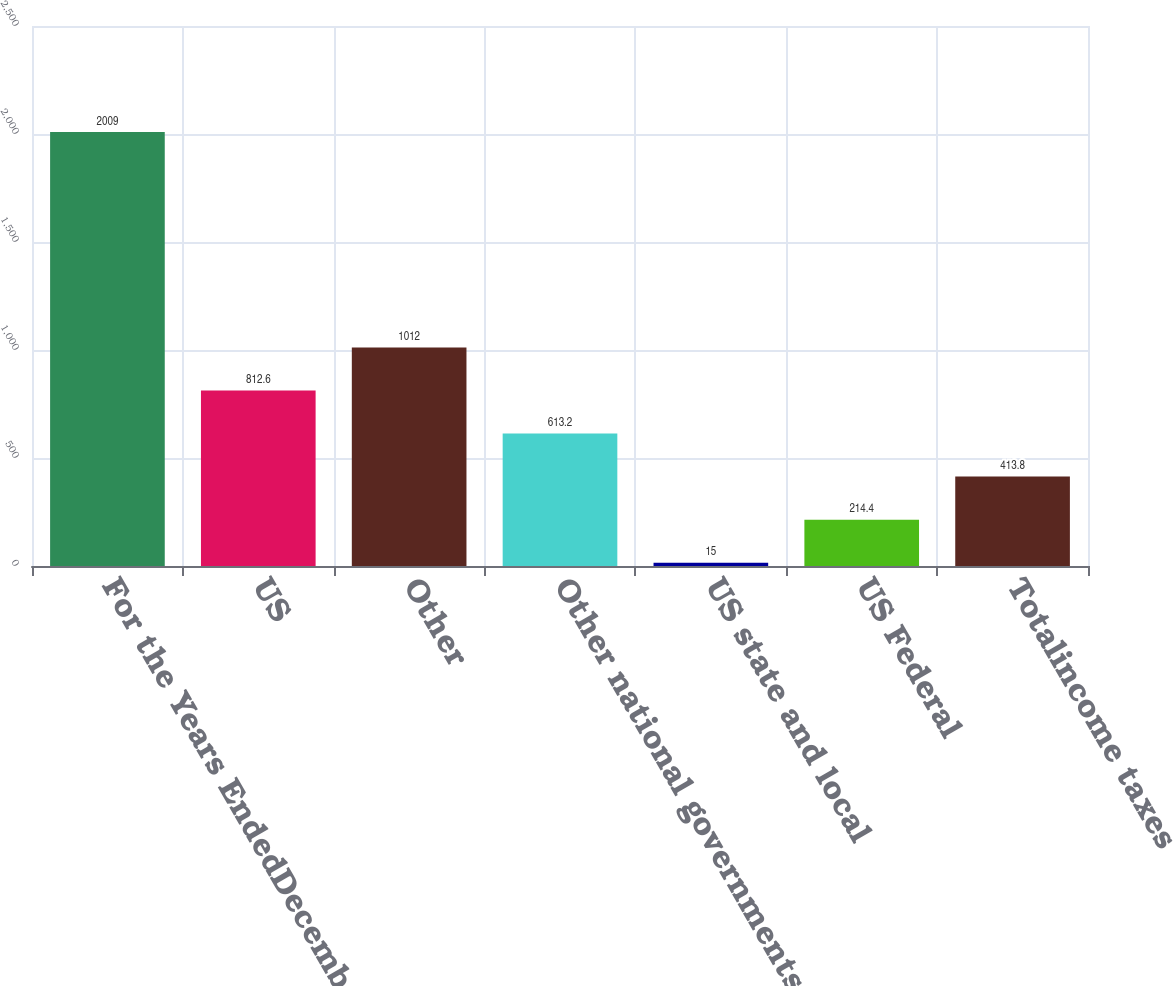<chart> <loc_0><loc_0><loc_500><loc_500><bar_chart><fcel>For the Years EndedDecember 31<fcel>US<fcel>Other<fcel>Other national governments<fcel>US state and local<fcel>US Federal<fcel>Totalincome taxes<nl><fcel>2009<fcel>812.6<fcel>1012<fcel>613.2<fcel>15<fcel>214.4<fcel>413.8<nl></chart> 